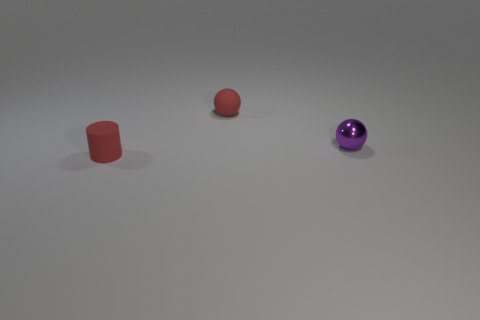What material is the tiny cylinder?
Your response must be concise. Rubber. The tiny rubber thing that is on the left side of the tiny red rubber object that is right of the tiny matte object that is on the left side of the small red ball is what shape?
Your answer should be compact. Cylinder. How many other objects are there of the same material as the purple object?
Provide a short and direct response. 0. Is the material of the tiny red object that is right of the small matte cylinder the same as the tiny purple object right of the red cylinder?
Your answer should be very brief. No. How many things are both behind the small red cylinder and in front of the small rubber ball?
Offer a terse response. 1. Is there another tiny shiny thing that has the same shape as the purple metallic thing?
Provide a short and direct response. No. There is a purple metal object that is the same size as the cylinder; what is its shape?
Give a very brief answer. Sphere. Are there an equal number of things that are behind the cylinder and things in front of the rubber ball?
Give a very brief answer. Yes. How big is the rubber thing that is behind the object right of the red matte sphere?
Provide a short and direct response. Small. Is there a metal sphere of the same size as the shiny object?
Keep it short and to the point. No. 